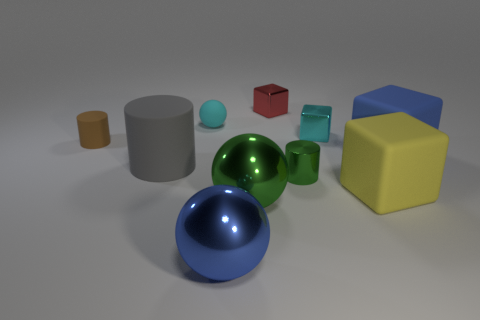Subtract 1 blocks. How many blocks are left? 3 Subtract all cubes. How many objects are left? 6 Subtract all big shiny balls. Subtract all gray matte cylinders. How many objects are left? 7 Add 8 gray rubber cylinders. How many gray rubber cylinders are left? 9 Add 4 big cyan shiny cubes. How many big cyan shiny cubes exist? 4 Subtract 0 purple cylinders. How many objects are left? 10 